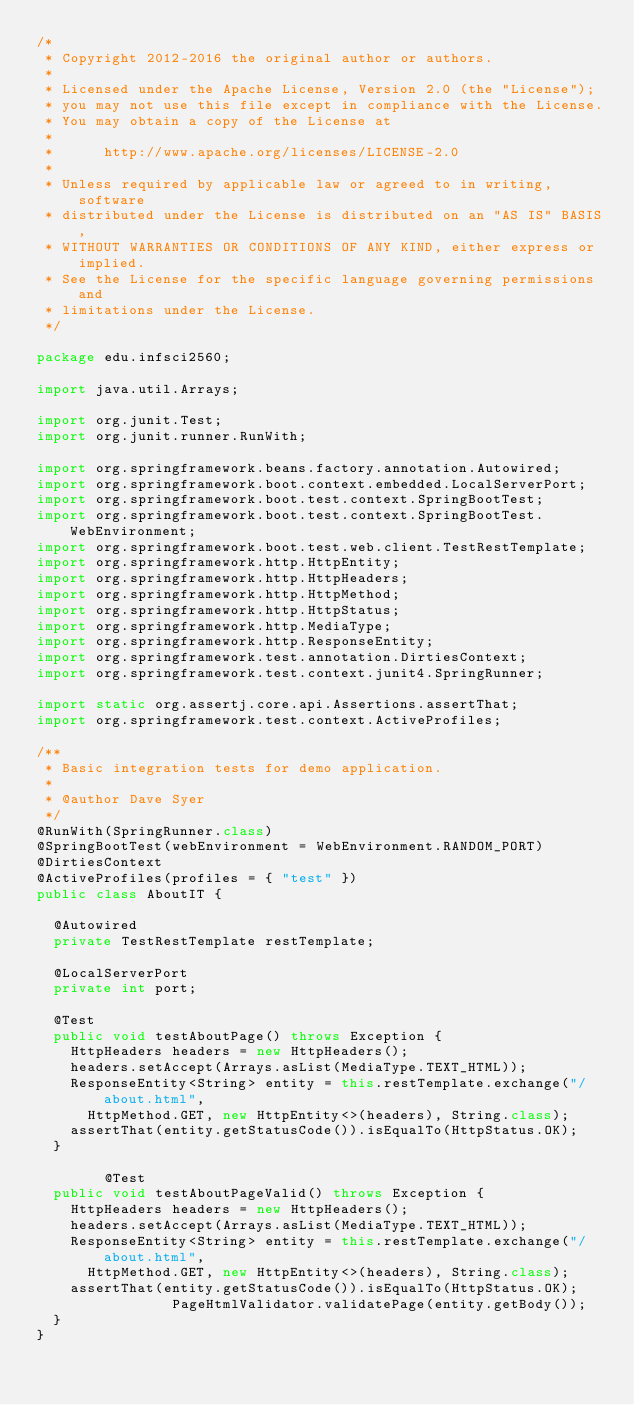Convert code to text. <code><loc_0><loc_0><loc_500><loc_500><_Java_>/*
 * Copyright 2012-2016 the original author or authors.
 *
 * Licensed under the Apache License, Version 2.0 (the "License");
 * you may not use this file except in compliance with the License.
 * You may obtain a copy of the License at
 *
 *      http://www.apache.org/licenses/LICENSE-2.0
 *
 * Unless required by applicable law or agreed to in writing, software
 * distributed under the License is distributed on an "AS IS" BASIS,
 * WITHOUT WARRANTIES OR CONDITIONS OF ANY KIND, either express or implied.
 * See the License for the specific language governing permissions and
 * limitations under the License.
 */

package edu.infsci2560;

import java.util.Arrays;

import org.junit.Test;
import org.junit.runner.RunWith;

import org.springframework.beans.factory.annotation.Autowired;
import org.springframework.boot.context.embedded.LocalServerPort;
import org.springframework.boot.test.context.SpringBootTest;
import org.springframework.boot.test.context.SpringBootTest.WebEnvironment;
import org.springframework.boot.test.web.client.TestRestTemplate;
import org.springframework.http.HttpEntity;
import org.springframework.http.HttpHeaders;
import org.springframework.http.HttpMethod;
import org.springframework.http.HttpStatus;
import org.springframework.http.MediaType;
import org.springframework.http.ResponseEntity;
import org.springframework.test.annotation.DirtiesContext;
import org.springframework.test.context.junit4.SpringRunner;

import static org.assertj.core.api.Assertions.assertThat;
import org.springframework.test.context.ActiveProfiles;

/**
 * Basic integration tests for demo application.
 *
 * @author Dave Syer
 */
@RunWith(SpringRunner.class)
@SpringBootTest(webEnvironment = WebEnvironment.RANDOM_PORT)
@DirtiesContext
@ActiveProfiles(profiles = { "test" })
public class AboutIT {

	@Autowired
	private TestRestTemplate restTemplate;

	@LocalServerPort
	private int port;

	@Test
	public void testAboutPage() throws Exception {
		HttpHeaders headers = new HttpHeaders();
		headers.setAccept(Arrays.asList(MediaType.TEXT_HTML));
		ResponseEntity<String> entity = this.restTemplate.exchange("/about.html", 
			HttpMethod.GET, new HttpEntity<>(headers), String.class);
		assertThat(entity.getStatusCode()).isEqualTo(HttpStatus.OK);
	}
        
        @Test
	public void testAboutPageValid() throws Exception {
		HttpHeaders headers = new HttpHeaders();
		headers.setAccept(Arrays.asList(MediaType.TEXT_HTML));
		ResponseEntity<String> entity = this.restTemplate.exchange("/about.html", 
			HttpMethod.GET, new HttpEntity<>(headers), String.class);
		assertThat(entity.getStatusCode()).isEqualTo(HttpStatus.OK);
                PageHtmlValidator.validatePage(entity.getBody());
	}
}</code> 